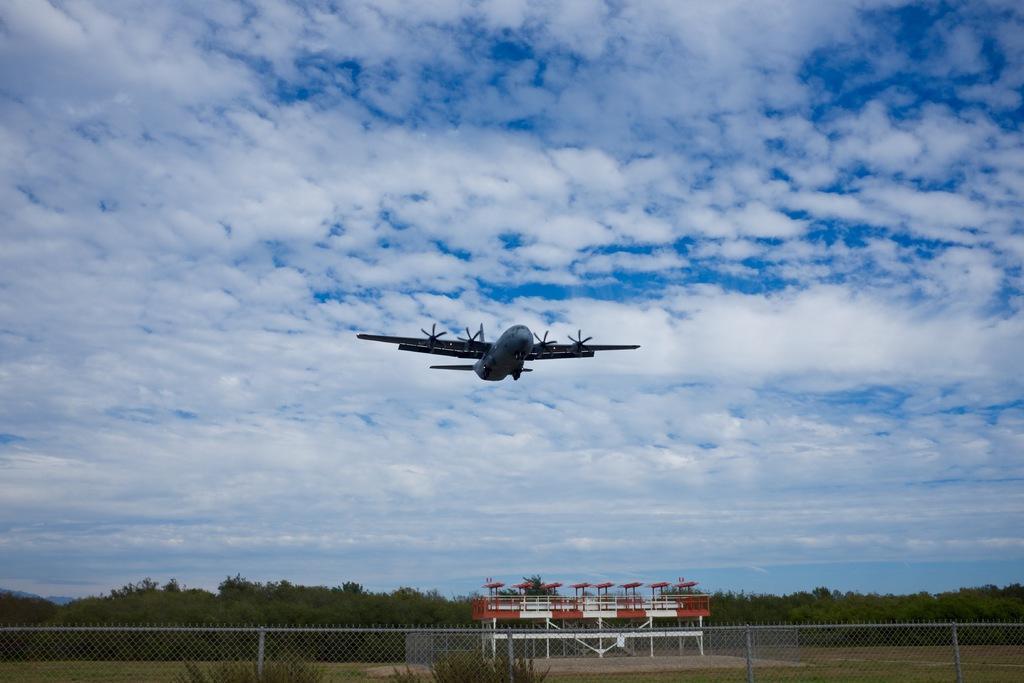In one or two sentences, can you explain what this image depicts? In the foreground of this image, there is an airplane in the air. At the bottom, there is fencing, greenery and the land. We can also see a shed like an object and trees behind it. At the top, there is the sky and the cloud. 